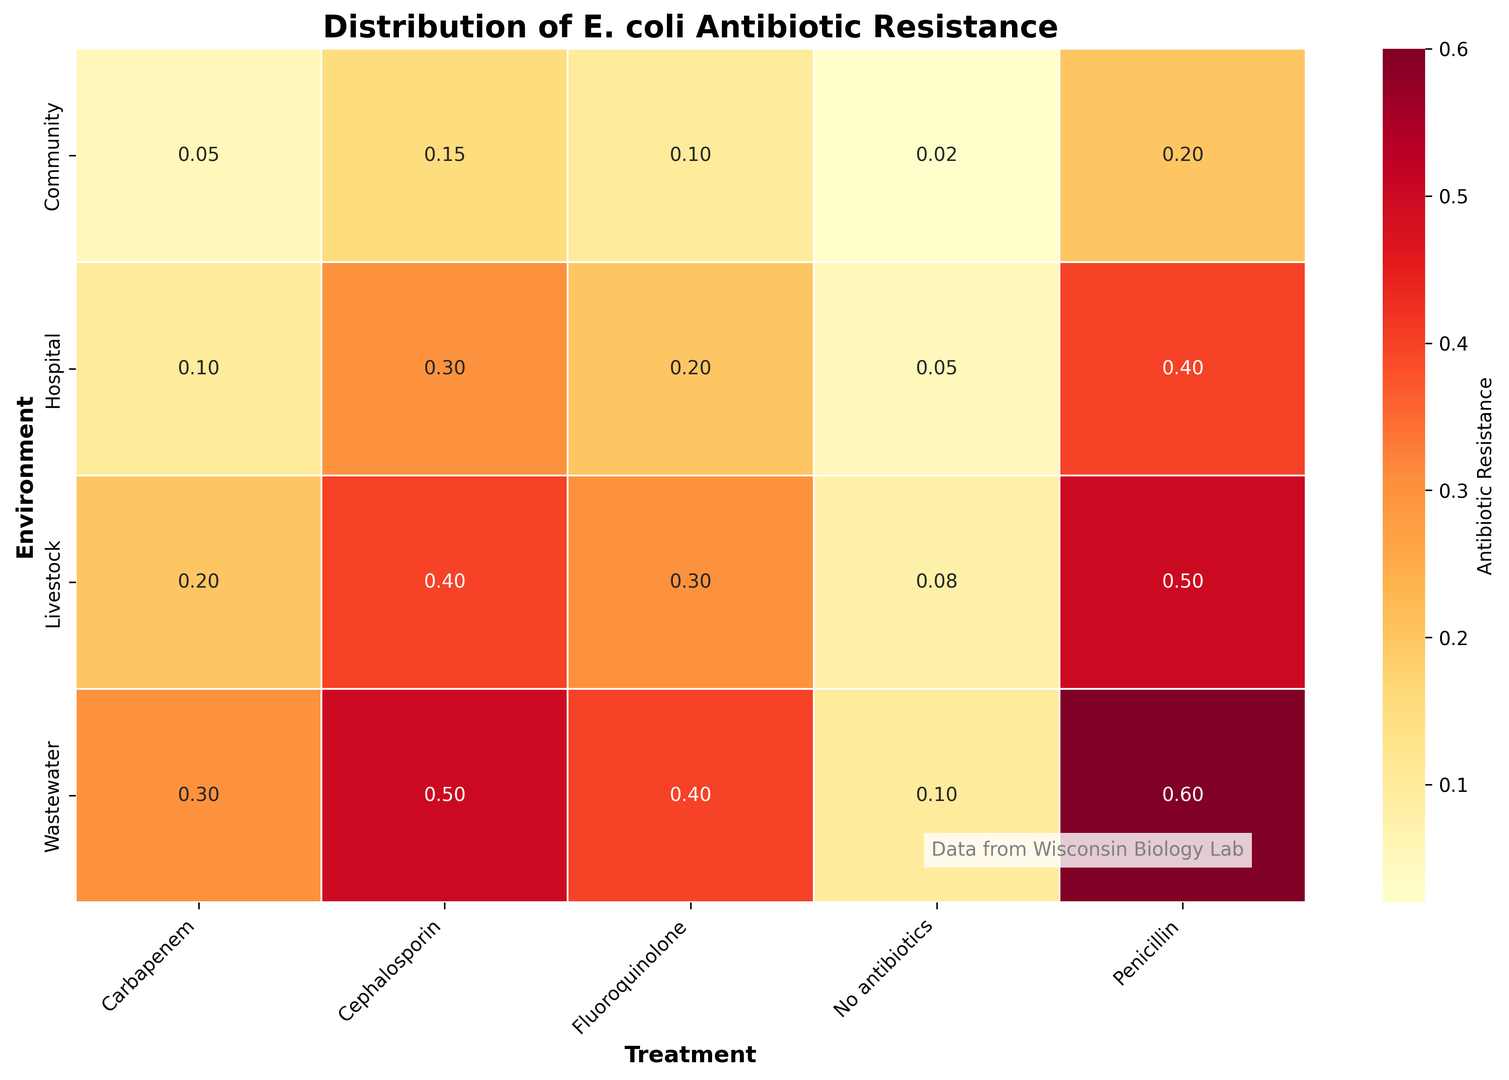Which environment and treatment combination shows the highest resistance in E. coli? By looking at the heatmap, find the cell with the darkest color corresponding to the highest value for E. coli resistance.
Answer: Wastewater, Penicillin Compare the antibiotic resistance of E. coli in the hospital environment with no antibiotics and carbapenem treatment. Which is higher? Find the values corresponding to the hospital environment for both the no antibiotics and carbapenem treatments. Compare these values.
Answer: No antibiotics What is the average antibiotic resistance of E. coli in the wastewater environment across all treatments? Sum the resistance values of E. coli in the wastewater environment for all treatments and divide by the number of treatments. (0.1 + 0.6 + 0.5 + 0.4 + 0.3) / 5 = 1.9 / 5 = 0.38
Answer: 0.38 Which treatment shows the highest average resistance in the community environment? Calculate the average resistance for each treatment in the community environment by summing the values for each bacterium and dividing by the number of bacteria. Find the highest average.
Answer: Penicillin What is the difference in E. coli resistance between the hospital and livestock environments for cephalosporin treatment? Subtract the value of E. coli resistance in the hospital from that in the livestock for cephalosporin treatment. 0.4 - 0.3 = 0.1
Answer: 0.1 Is E. coli resistance higher in the community or hospital environment without antibiotic treatment? Compare the resistance values of E. coli in the community and hospital environments without antibiotic treatment.
Answer: Hospital What is the sum of E. coli resistance in all environments for fluoroquinolone treatment? Add the E. coli resistance values for fluoroquinolone treatment across all environments. 0.2 + 0.1 + 0.3 + 0.4 = 1.0
Answer: 1.0 Which environment has the highest variance in E. coli resistance across all treatments? Calculate the variance in resistance values for each environment and compare. The environment with the highest variance has the most spread-out values.
Answer: Wastewater How does E. coli resistance in community environments compare to hospital environments for penicillin treatment? Find the E. coli resistance values in the community and hospital environments for penicillin treatment and compare them.
Answer: Lower in Community For carbapenem treatment, what is the ratio of E. coli resistance in the livestock environment to that in the hospital environment? Divide the E. coli resistance value in the livestock environment by that in the hospital environment for carbapenem treatment. 0.2 / 0.1 = 2.0
Answer: 2.0 